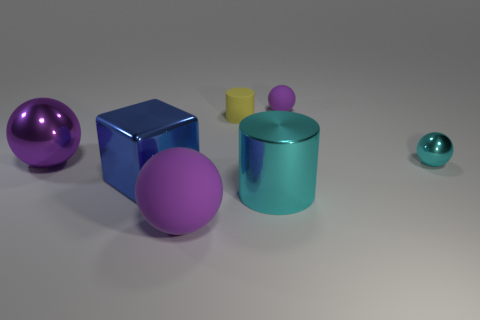Is the color of the matte sphere to the right of the big purple rubber sphere the same as the small cylinder?
Ensure brevity in your answer.  No. What number of cylinders are on the right side of the yellow object?
Give a very brief answer. 1. Are the yellow cylinder and the big purple thing that is in front of the large blue shiny block made of the same material?
Offer a very short reply. Yes. What size is the blue block that is made of the same material as the big cylinder?
Provide a short and direct response. Large. Is the number of objects left of the shiny cube greater than the number of tiny purple matte spheres in front of the large cyan metallic object?
Your answer should be very brief. Yes. Is there a small brown shiny object of the same shape as the large cyan shiny thing?
Offer a very short reply. No. There is a purple matte object in front of the cyan cylinder; is it the same size as the shiny cube?
Keep it short and to the point. Yes. Is there a small metal object?
Offer a terse response. Yes. How many things are metal objects that are in front of the blue metal thing or shiny cubes?
Your answer should be compact. 2. Does the tiny metal object have the same color as the big object that is behind the tiny metallic thing?
Your answer should be very brief. No. 